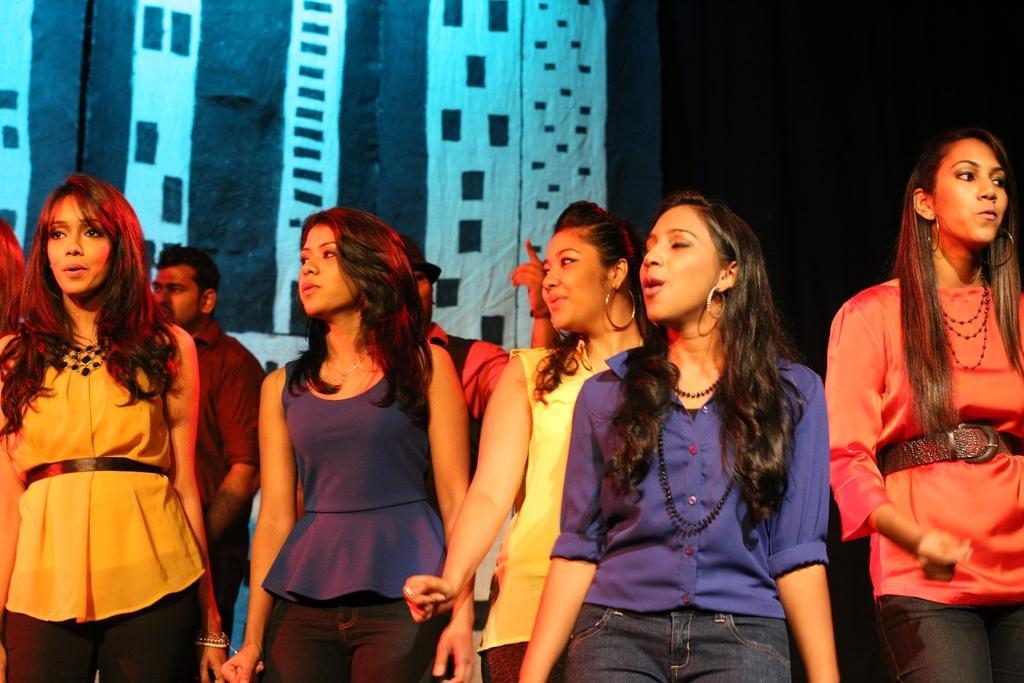Describe this image in one or two sentences. In the foreground of the picture there are women standing. In the background there are two men. At the top there are curtains. 